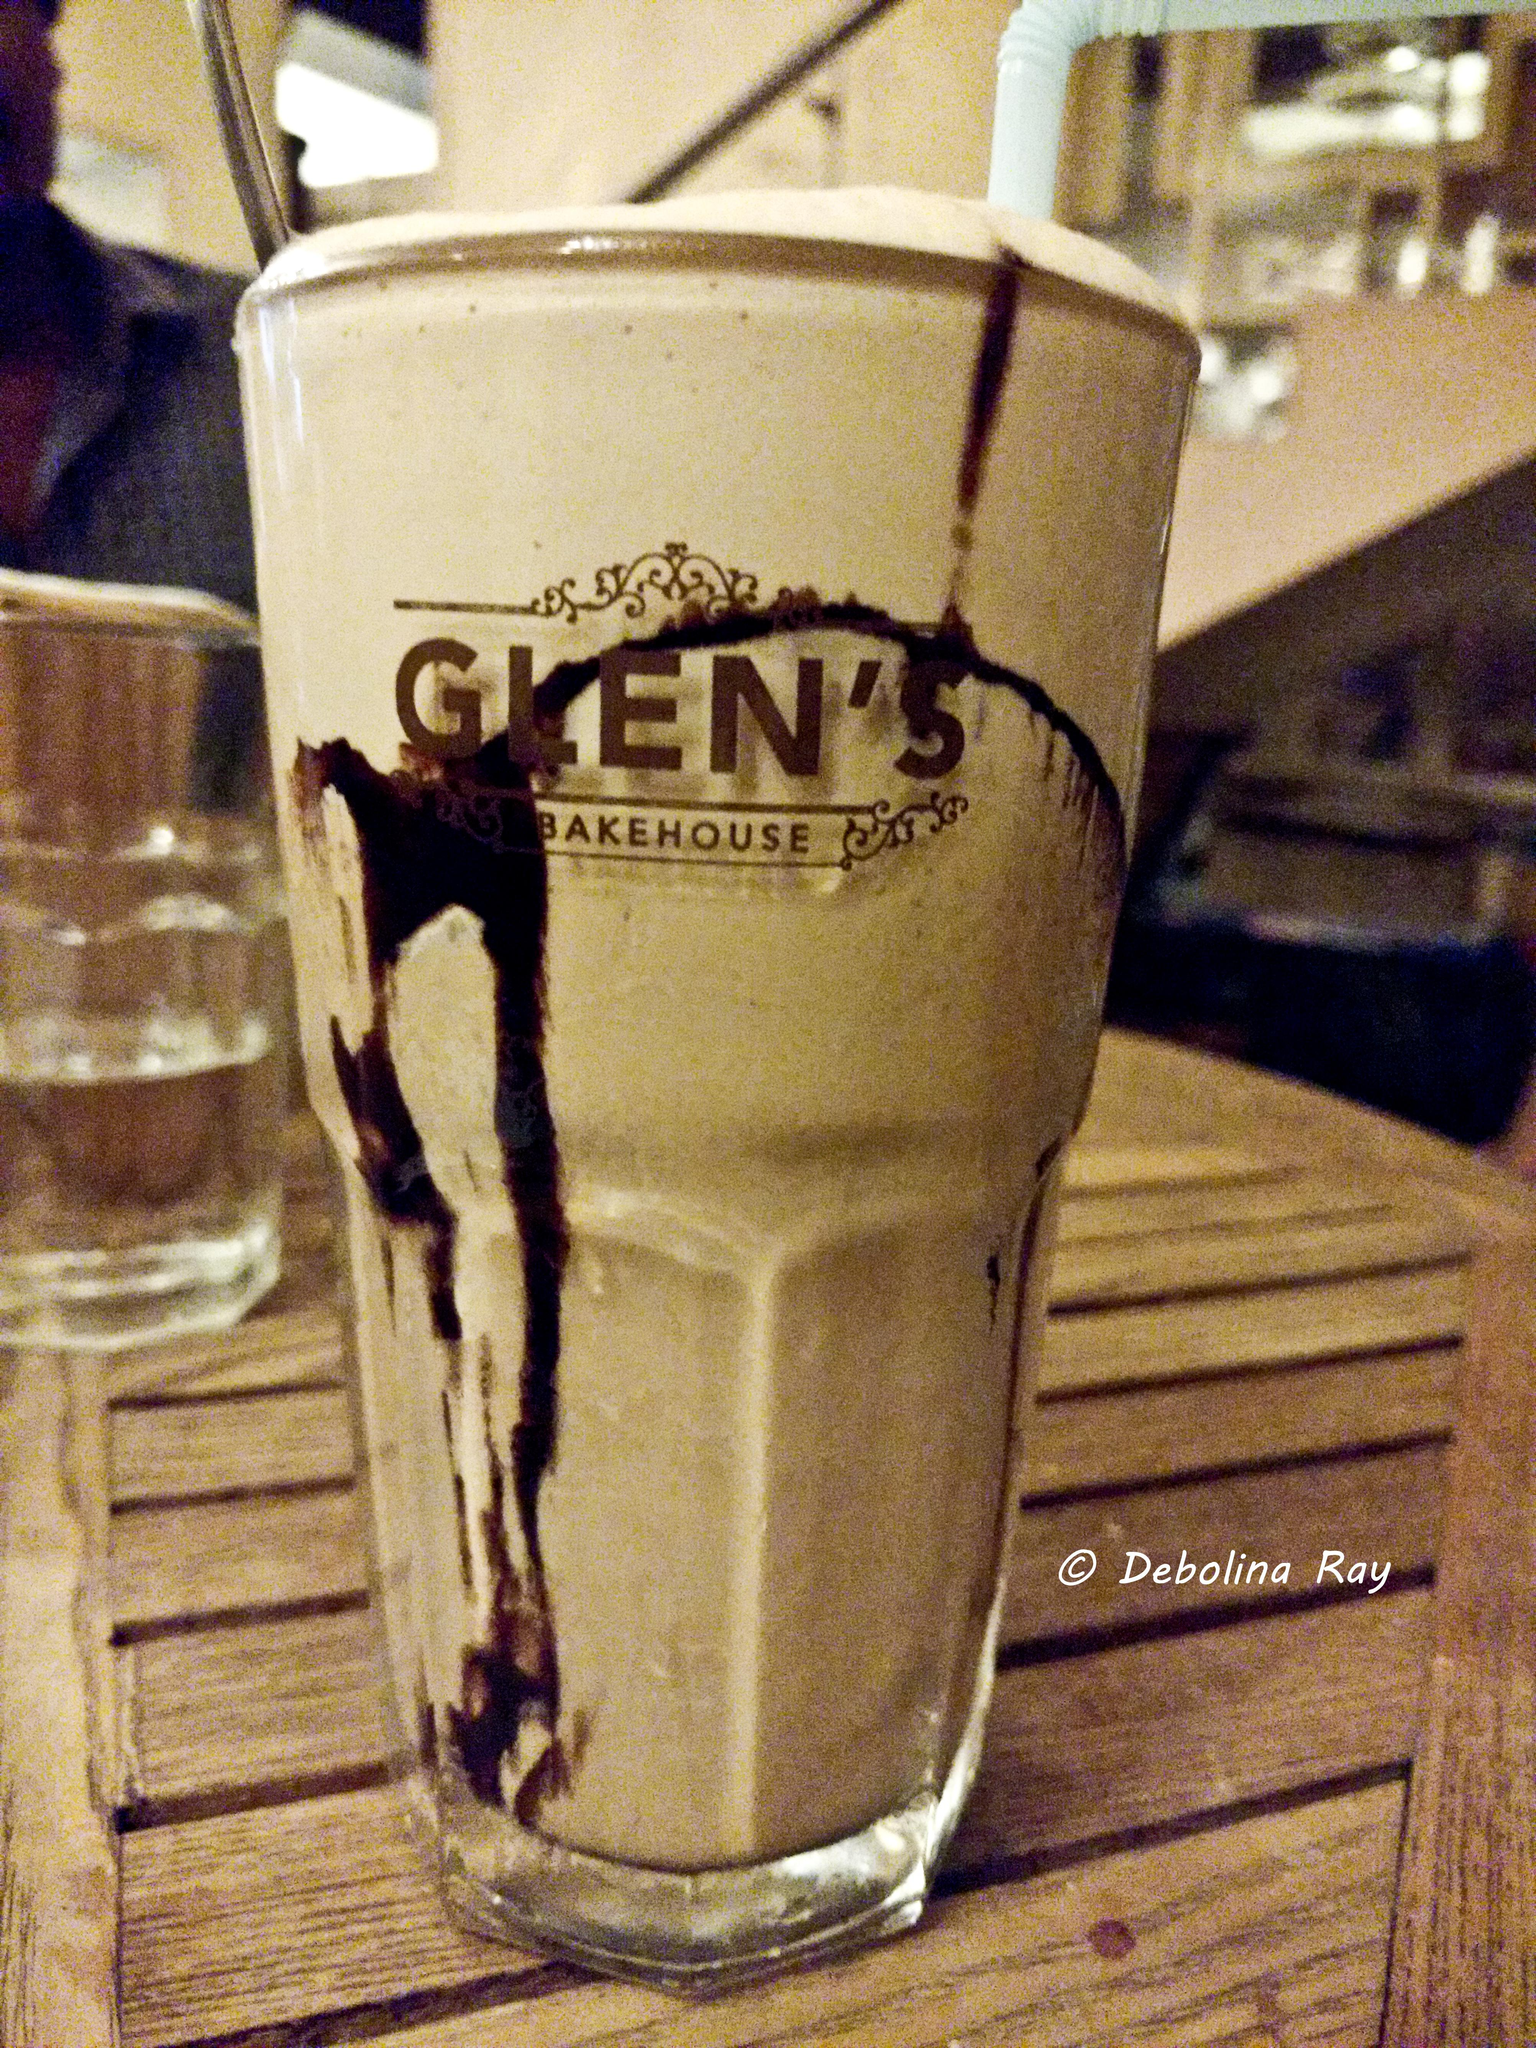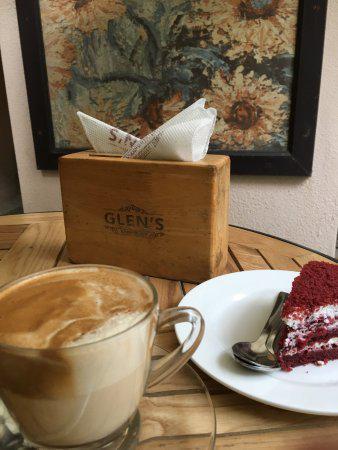The first image is the image on the left, the second image is the image on the right. Evaluate the accuracy of this statement regarding the images: "The right image shows round frosted cake-type desserts displayed on round glass shelves in a tall glass-fronted case.". Is it true? Answer yes or no. No. 